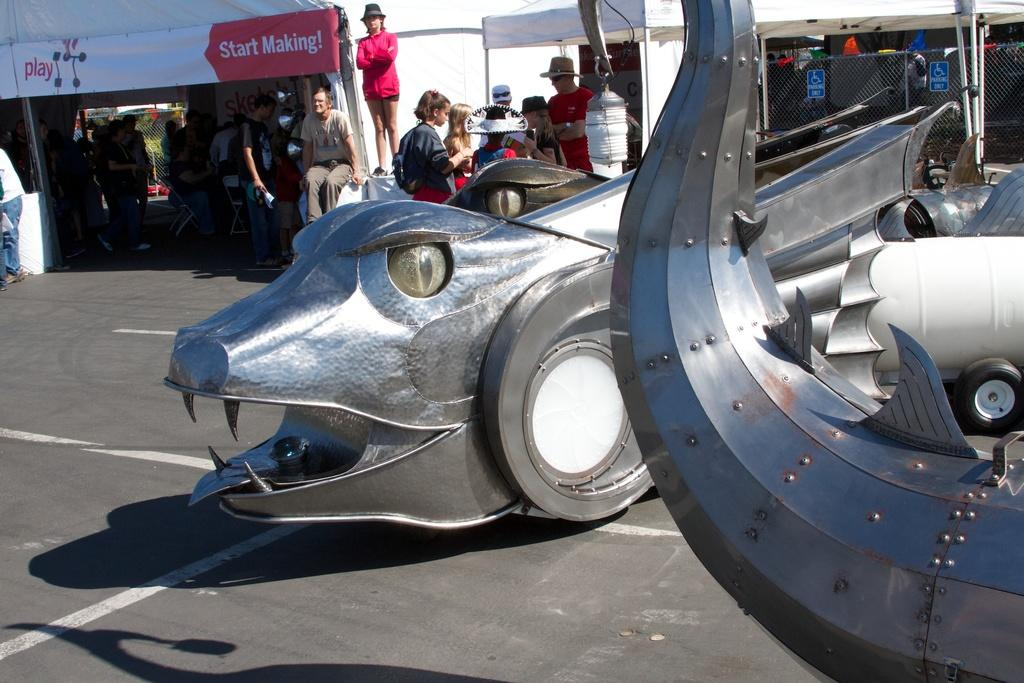What type of objects can be seen in the image? There are decorative items in the image. What can be observed in the background of the image? There are many people, tents, poles, and fencing in the background of the image. What type of haircut is being given to the person in the image? There is no person getting a haircut in the image; it only features decorative items and the background elements mentioned earlier. 